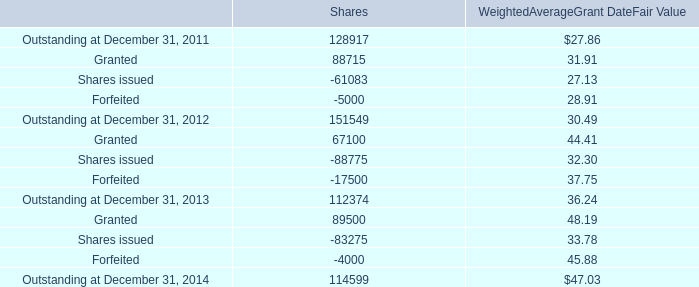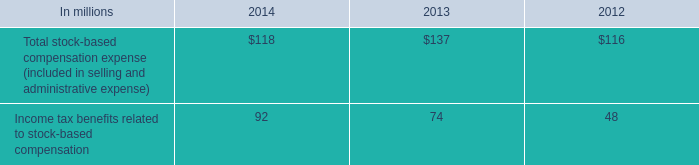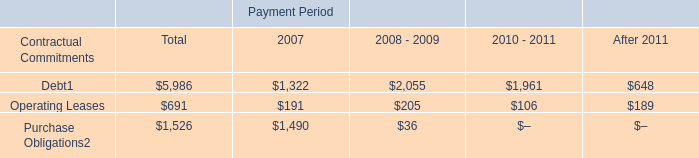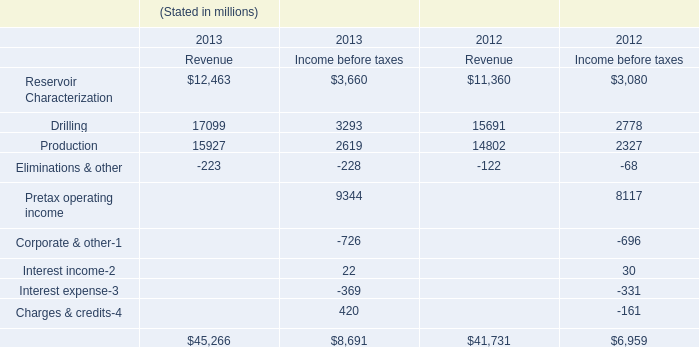What's the sum of the Outstanding at December 31, in the years where Income tax benefits related to stock-based compensation is positive? 
Computations: ((114599 + 112374) + 151549)
Answer: 378522.0. 